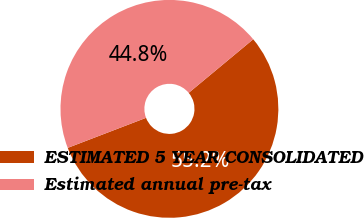Convert chart. <chart><loc_0><loc_0><loc_500><loc_500><pie_chart><fcel>ESTIMATED 5 YEAR CONSOLIDATED<fcel>Estimated annual pre-tax<nl><fcel>55.2%<fcel>44.8%<nl></chart> 